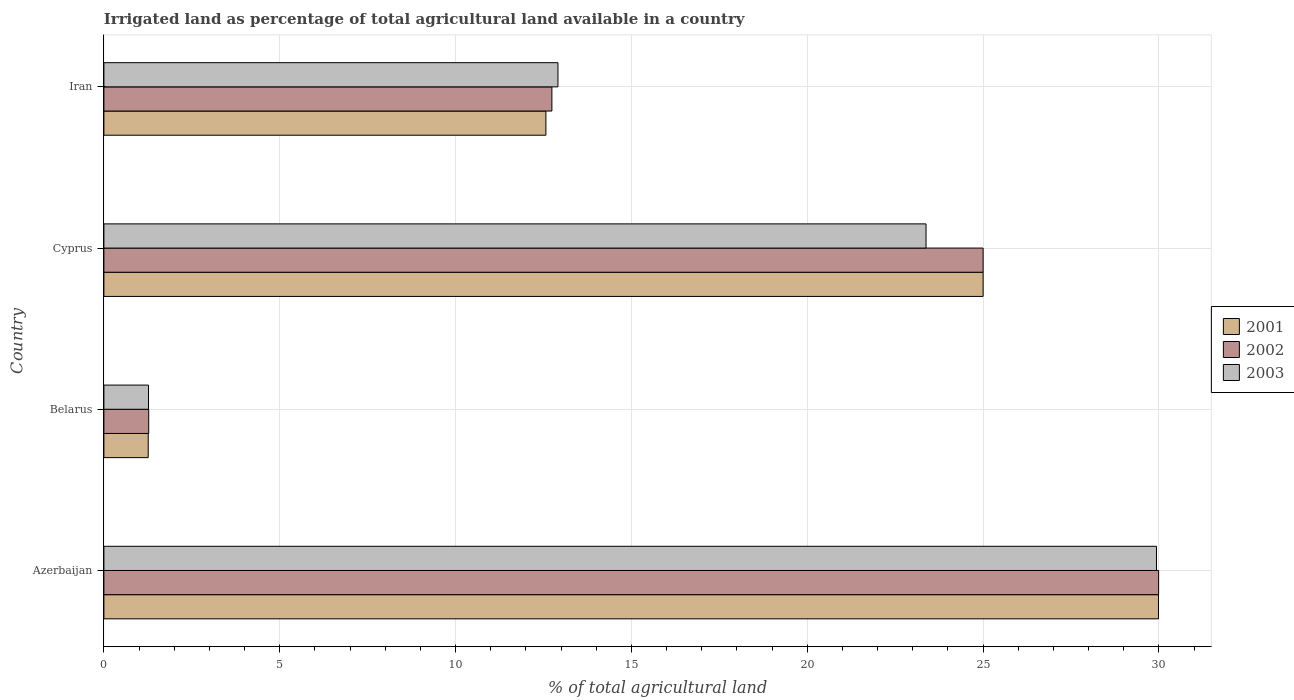How many different coloured bars are there?
Keep it short and to the point. 3. How many bars are there on the 3rd tick from the bottom?
Give a very brief answer. 3. What is the label of the 3rd group of bars from the top?
Provide a short and direct response. Belarus. In how many cases, is the number of bars for a given country not equal to the number of legend labels?
Offer a terse response. 0. What is the percentage of irrigated land in 2002 in Azerbaijan?
Provide a succinct answer. 29.99. Across all countries, what is the maximum percentage of irrigated land in 2001?
Provide a short and direct response. 29.99. Across all countries, what is the minimum percentage of irrigated land in 2001?
Provide a short and direct response. 1.26. In which country was the percentage of irrigated land in 2003 maximum?
Offer a very short reply. Azerbaijan. In which country was the percentage of irrigated land in 2003 minimum?
Keep it short and to the point. Belarus. What is the total percentage of irrigated land in 2002 in the graph?
Your response must be concise. 69. What is the difference between the percentage of irrigated land in 2003 in Azerbaijan and that in Cyprus?
Provide a short and direct response. 6.55. What is the difference between the percentage of irrigated land in 2003 in Cyprus and the percentage of irrigated land in 2002 in Azerbaijan?
Provide a short and direct response. -6.61. What is the average percentage of irrigated land in 2003 per country?
Provide a short and direct response. 16.87. What is the difference between the percentage of irrigated land in 2001 and percentage of irrigated land in 2002 in Belarus?
Keep it short and to the point. -0.01. In how many countries, is the percentage of irrigated land in 2002 greater than 4 %?
Ensure brevity in your answer.  3. What is the ratio of the percentage of irrigated land in 2002 in Belarus to that in Cyprus?
Provide a succinct answer. 0.05. What is the difference between the highest and the second highest percentage of irrigated land in 2001?
Keep it short and to the point. 4.99. What is the difference between the highest and the lowest percentage of irrigated land in 2002?
Give a very brief answer. 28.72. In how many countries, is the percentage of irrigated land in 2001 greater than the average percentage of irrigated land in 2001 taken over all countries?
Provide a succinct answer. 2. Is the sum of the percentage of irrigated land in 2002 in Azerbaijan and Iran greater than the maximum percentage of irrigated land in 2001 across all countries?
Provide a succinct answer. Yes. What does the 1st bar from the bottom in Azerbaijan represents?
Your answer should be very brief. 2001. Is it the case that in every country, the sum of the percentage of irrigated land in 2001 and percentage of irrigated land in 2003 is greater than the percentage of irrigated land in 2002?
Offer a very short reply. Yes. Are all the bars in the graph horizontal?
Provide a short and direct response. Yes. How many countries are there in the graph?
Your answer should be very brief. 4. What is the difference between two consecutive major ticks on the X-axis?
Your answer should be very brief. 5. Where does the legend appear in the graph?
Provide a short and direct response. Center right. How many legend labels are there?
Your answer should be very brief. 3. What is the title of the graph?
Keep it short and to the point. Irrigated land as percentage of total agricultural land available in a country. Does "1966" appear as one of the legend labels in the graph?
Offer a very short reply. No. What is the label or title of the X-axis?
Give a very brief answer. % of total agricultural land. What is the % of total agricultural land in 2001 in Azerbaijan?
Your response must be concise. 29.99. What is the % of total agricultural land in 2002 in Azerbaijan?
Offer a terse response. 29.99. What is the % of total agricultural land in 2003 in Azerbaijan?
Provide a succinct answer. 29.93. What is the % of total agricultural land in 2001 in Belarus?
Give a very brief answer. 1.26. What is the % of total agricultural land in 2002 in Belarus?
Your response must be concise. 1.27. What is the % of total agricultural land in 2003 in Belarus?
Make the answer very short. 1.27. What is the % of total agricultural land of 2001 in Cyprus?
Make the answer very short. 25. What is the % of total agricultural land of 2003 in Cyprus?
Keep it short and to the point. 23.38. What is the % of total agricultural land of 2001 in Iran?
Ensure brevity in your answer.  12.57. What is the % of total agricultural land in 2002 in Iran?
Give a very brief answer. 12.74. What is the % of total agricultural land of 2003 in Iran?
Keep it short and to the point. 12.91. Across all countries, what is the maximum % of total agricultural land of 2001?
Offer a terse response. 29.99. Across all countries, what is the maximum % of total agricultural land in 2002?
Make the answer very short. 29.99. Across all countries, what is the maximum % of total agricultural land of 2003?
Your response must be concise. 29.93. Across all countries, what is the minimum % of total agricultural land of 2001?
Offer a terse response. 1.26. Across all countries, what is the minimum % of total agricultural land in 2002?
Offer a terse response. 1.27. Across all countries, what is the minimum % of total agricultural land of 2003?
Ensure brevity in your answer.  1.27. What is the total % of total agricultural land of 2001 in the graph?
Give a very brief answer. 68.81. What is the total % of total agricultural land of 2002 in the graph?
Give a very brief answer. 69. What is the total % of total agricultural land in 2003 in the graph?
Offer a very short reply. 67.48. What is the difference between the % of total agricultural land in 2001 in Azerbaijan and that in Belarus?
Your answer should be very brief. 28.73. What is the difference between the % of total agricultural land in 2002 in Azerbaijan and that in Belarus?
Your answer should be very brief. 28.72. What is the difference between the % of total agricultural land of 2003 in Azerbaijan and that in Belarus?
Offer a very short reply. 28.66. What is the difference between the % of total agricultural land of 2001 in Azerbaijan and that in Cyprus?
Your answer should be compact. 4.99. What is the difference between the % of total agricultural land in 2002 in Azerbaijan and that in Cyprus?
Provide a succinct answer. 4.99. What is the difference between the % of total agricultural land of 2003 in Azerbaijan and that in Cyprus?
Give a very brief answer. 6.55. What is the difference between the % of total agricultural land in 2001 in Azerbaijan and that in Iran?
Your answer should be compact. 17.42. What is the difference between the % of total agricultural land of 2002 in Azerbaijan and that in Iran?
Provide a succinct answer. 17.25. What is the difference between the % of total agricultural land of 2003 in Azerbaijan and that in Iran?
Ensure brevity in your answer.  17.02. What is the difference between the % of total agricultural land in 2001 in Belarus and that in Cyprus?
Ensure brevity in your answer.  -23.74. What is the difference between the % of total agricultural land of 2002 in Belarus and that in Cyprus?
Ensure brevity in your answer.  -23.73. What is the difference between the % of total agricultural land of 2003 in Belarus and that in Cyprus?
Ensure brevity in your answer.  -22.11. What is the difference between the % of total agricultural land in 2001 in Belarus and that in Iran?
Your response must be concise. -11.31. What is the difference between the % of total agricultural land of 2002 in Belarus and that in Iran?
Keep it short and to the point. -11.46. What is the difference between the % of total agricultural land in 2003 in Belarus and that in Iran?
Provide a succinct answer. -11.64. What is the difference between the % of total agricultural land in 2001 in Cyprus and that in Iran?
Your response must be concise. 12.43. What is the difference between the % of total agricultural land in 2002 in Cyprus and that in Iran?
Offer a very short reply. 12.26. What is the difference between the % of total agricultural land of 2003 in Cyprus and that in Iran?
Your answer should be compact. 10.47. What is the difference between the % of total agricultural land of 2001 in Azerbaijan and the % of total agricultural land of 2002 in Belarus?
Keep it short and to the point. 28.71. What is the difference between the % of total agricultural land of 2001 in Azerbaijan and the % of total agricultural land of 2003 in Belarus?
Keep it short and to the point. 28.72. What is the difference between the % of total agricultural land of 2002 in Azerbaijan and the % of total agricultural land of 2003 in Belarus?
Your response must be concise. 28.72. What is the difference between the % of total agricultural land of 2001 in Azerbaijan and the % of total agricultural land of 2002 in Cyprus?
Provide a succinct answer. 4.99. What is the difference between the % of total agricultural land of 2001 in Azerbaijan and the % of total agricultural land of 2003 in Cyprus?
Keep it short and to the point. 6.61. What is the difference between the % of total agricultural land in 2002 in Azerbaijan and the % of total agricultural land in 2003 in Cyprus?
Provide a short and direct response. 6.61. What is the difference between the % of total agricultural land of 2001 in Azerbaijan and the % of total agricultural land of 2002 in Iran?
Keep it short and to the point. 17.25. What is the difference between the % of total agricultural land in 2001 in Azerbaijan and the % of total agricultural land in 2003 in Iran?
Your answer should be very brief. 17.08. What is the difference between the % of total agricultural land in 2002 in Azerbaijan and the % of total agricultural land in 2003 in Iran?
Your response must be concise. 17.08. What is the difference between the % of total agricultural land of 2001 in Belarus and the % of total agricultural land of 2002 in Cyprus?
Offer a terse response. -23.74. What is the difference between the % of total agricultural land in 2001 in Belarus and the % of total agricultural land in 2003 in Cyprus?
Your response must be concise. -22.12. What is the difference between the % of total agricultural land of 2002 in Belarus and the % of total agricultural land of 2003 in Cyprus?
Offer a terse response. -22.1. What is the difference between the % of total agricultural land in 2001 in Belarus and the % of total agricultural land in 2002 in Iran?
Ensure brevity in your answer.  -11.48. What is the difference between the % of total agricultural land in 2001 in Belarus and the % of total agricultural land in 2003 in Iran?
Your answer should be compact. -11.65. What is the difference between the % of total agricultural land in 2002 in Belarus and the % of total agricultural land in 2003 in Iran?
Offer a very short reply. -11.64. What is the difference between the % of total agricultural land of 2001 in Cyprus and the % of total agricultural land of 2002 in Iran?
Give a very brief answer. 12.26. What is the difference between the % of total agricultural land in 2001 in Cyprus and the % of total agricultural land in 2003 in Iran?
Provide a short and direct response. 12.09. What is the difference between the % of total agricultural land of 2002 in Cyprus and the % of total agricultural land of 2003 in Iran?
Your response must be concise. 12.09. What is the average % of total agricultural land of 2001 per country?
Ensure brevity in your answer.  17.2. What is the average % of total agricultural land of 2002 per country?
Provide a succinct answer. 17.25. What is the average % of total agricultural land in 2003 per country?
Offer a very short reply. 16.87. What is the difference between the % of total agricultural land in 2001 and % of total agricultural land in 2002 in Azerbaijan?
Give a very brief answer. -0. What is the difference between the % of total agricultural land in 2001 and % of total agricultural land in 2003 in Azerbaijan?
Ensure brevity in your answer.  0.06. What is the difference between the % of total agricultural land of 2002 and % of total agricultural land of 2003 in Azerbaijan?
Give a very brief answer. 0.06. What is the difference between the % of total agricultural land in 2001 and % of total agricultural land in 2002 in Belarus?
Keep it short and to the point. -0.01. What is the difference between the % of total agricultural land of 2001 and % of total agricultural land of 2003 in Belarus?
Provide a succinct answer. -0.01. What is the difference between the % of total agricultural land of 2002 and % of total agricultural land of 2003 in Belarus?
Your answer should be compact. 0.01. What is the difference between the % of total agricultural land in 2001 and % of total agricultural land in 2003 in Cyprus?
Provide a succinct answer. 1.62. What is the difference between the % of total agricultural land in 2002 and % of total agricultural land in 2003 in Cyprus?
Ensure brevity in your answer.  1.62. What is the difference between the % of total agricultural land of 2001 and % of total agricultural land of 2002 in Iran?
Your answer should be very brief. -0.17. What is the difference between the % of total agricultural land of 2001 and % of total agricultural land of 2003 in Iran?
Ensure brevity in your answer.  -0.34. What is the difference between the % of total agricultural land of 2002 and % of total agricultural land of 2003 in Iran?
Provide a short and direct response. -0.17. What is the ratio of the % of total agricultural land of 2001 in Azerbaijan to that in Belarus?
Your response must be concise. 23.8. What is the ratio of the % of total agricultural land of 2002 in Azerbaijan to that in Belarus?
Offer a very short reply. 23.54. What is the ratio of the % of total agricultural land of 2003 in Azerbaijan to that in Belarus?
Make the answer very short. 23.59. What is the ratio of the % of total agricultural land of 2001 in Azerbaijan to that in Cyprus?
Provide a short and direct response. 1.2. What is the ratio of the % of total agricultural land in 2002 in Azerbaijan to that in Cyprus?
Provide a succinct answer. 1.2. What is the ratio of the % of total agricultural land of 2003 in Azerbaijan to that in Cyprus?
Keep it short and to the point. 1.28. What is the ratio of the % of total agricultural land in 2001 in Azerbaijan to that in Iran?
Provide a short and direct response. 2.39. What is the ratio of the % of total agricultural land in 2002 in Azerbaijan to that in Iran?
Provide a short and direct response. 2.35. What is the ratio of the % of total agricultural land in 2003 in Azerbaijan to that in Iran?
Give a very brief answer. 2.32. What is the ratio of the % of total agricultural land in 2001 in Belarus to that in Cyprus?
Provide a short and direct response. 0.05. What is the ratio of the % of total agricultural land in 2002 in Belarus to that in Cyprus?
Offer a very short reply. 0.05. What is the ratio of the % of total agricultural land of 2003 in Belarus to that in Cyprus?
Your answer should be very brief. 0.05. What is the ratio of the % of total agricultural land of 2001 in Belarus to that in Iran?
Your answer should be very brief. 0.1. What is the ratio of the % of total agricultural land in 2003 in Belarus to that in Iran?
Give a very brief answer. 0.1. What is the ratio of the % of total agricultural land in 2001 in Cyprus to that in Iran?
Keep it short and to the point. 1.99. What is the ratio of the % of total agricultural land in 2002 in Cyprus to that in Iran?
Your answer should be very brief. 1.96. What is the ratio of the % of total agricultural land of 2003 in Cyprus to that in Iran?
Your answer should be very brief. 1.81. What is the difference between the highest and the second highest % of total agricultural land of 2001?
Ensure brevity in your answer.  4.99. What is the difference between the highest and the second highest % of total agricultural land of 2002?
Make the answer very short. 4.99. What is the difference between the highest and the second highest % of total agricultural land of 2003?
Your response must be concise. 6.55. What is the difference between the highest and the lowest % of total agricultural land of 2001?
Make the answer very short. 28.73. What is the difference between the highest and the lowest % of total agricultural land of 2002?
Provide a succinct answer. 28.72. What is the difference between the highest and the lowest % of total agricultural land in 2003?
Give a very brief answer. 28.66. 